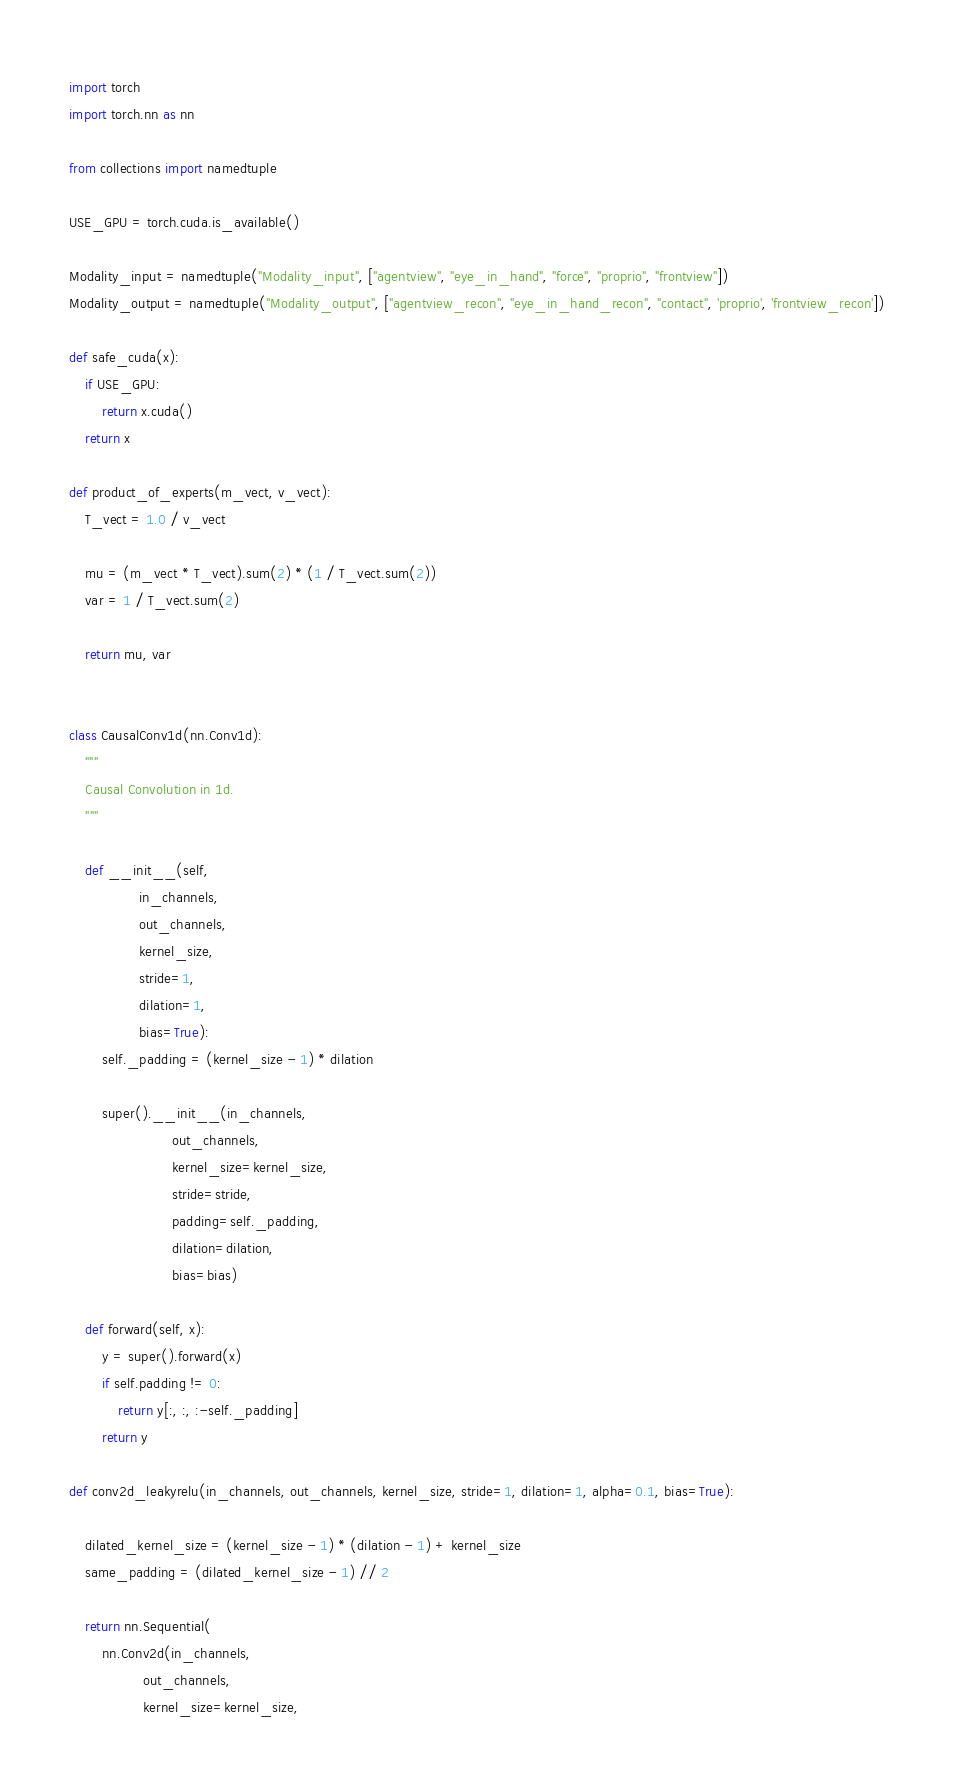Convert code to text. <code><loc_0><loc_0><loc_500><loc_500><_Python_>import torch
import torch.nn as nn

from collections import namedtuple

USE_GPU = torch.cuda.is_available()

Modality_input = namedtuple("Modality_input", ["agentview", "eye_in_hand", "force", "proprio", "frontview"])
Modality_output = namedtuple("Modality_output", ["agentview_recon", "eye_in_hand_recon", "contact", 'proprio', 'frontview_recon'])

def safe_cuda(x):
    if USE_GPU:
        return x.cuda()
    return x

def product_of_experts(m_vect, v_vect):
    T_vect = 1.0 / v_vect

    mu = (m_vect * T_vect).sum(2) * (1 / T_vect.sum(2))
    var = 1 / T_vect.sum(2)

    return mu, var


class CausalConv1d(nn.Conv1d):
    """
    Causal Convolution in 1d.
    """

    def __init__(self,
                 in_channels,
                 out_channels,
                 kernel_size,
                 stride=1,
                 dilation=1,
                 bias=True):
        self._padding = (kernel_size - 1) * dilation

        super().__init__(in_channels,
                         out_channels,
                         kernel_size=kernel_size,
                         stride=stride,
                         padding=self._padding,
                         dilation=dilation,
                         bias=bias)

    def forward(self, x):
        y = super().forward(x)
        if self.padding != 0:
            return y[:, :, :-self._padding]
        return y

def conv2d_leakyrelu(in_channels, out_channels, kernel_size, stride=1, dilation=1, alpha=0.1, bias=True):

    dilated_kernel_size = (kernel_size - 1) * (dilation - 1) + kernel_size
    same_padding = (dilated_kernel_size - 1) // 2

    return nn.Sequential(
        nn.Conv2d(in_channels,
                  out_channels,
                  kernel_size=kernel_size,</code> 